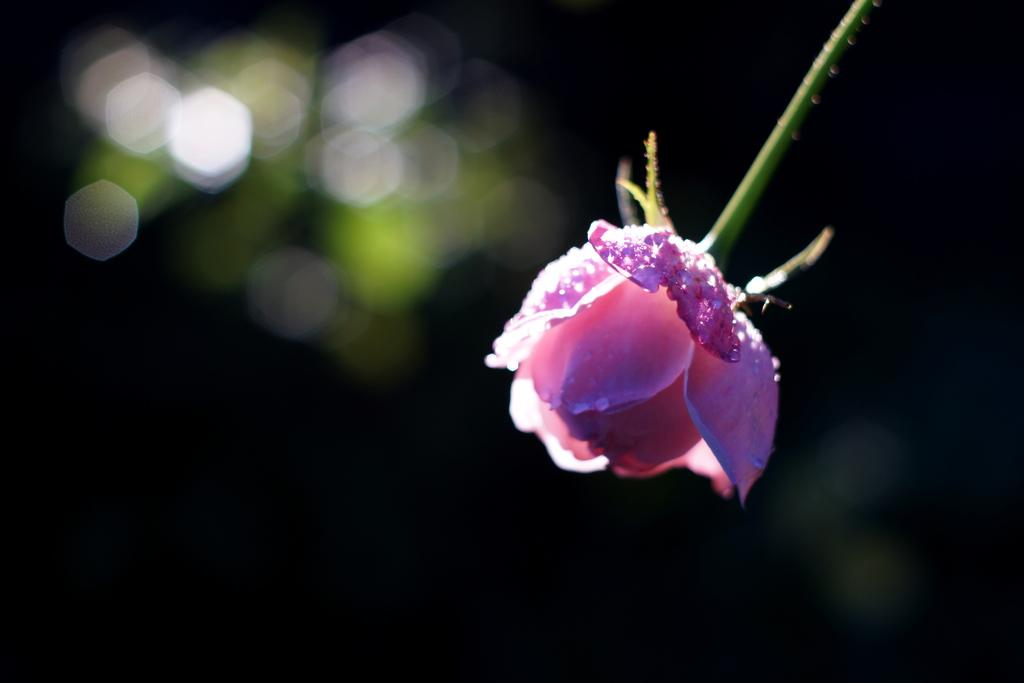What is the main subject in the front of the image? There is a flower in the front of the image. Can you describe the background of the image? The background of the image is blurry. What type of coach can be seen in the background of the image? There is no coach present in the image; the background is blurry. What season is depicted in the image, considering the presence of winter elements? There are no winter elements present in the image, as it only features a flower and a blurry background. 